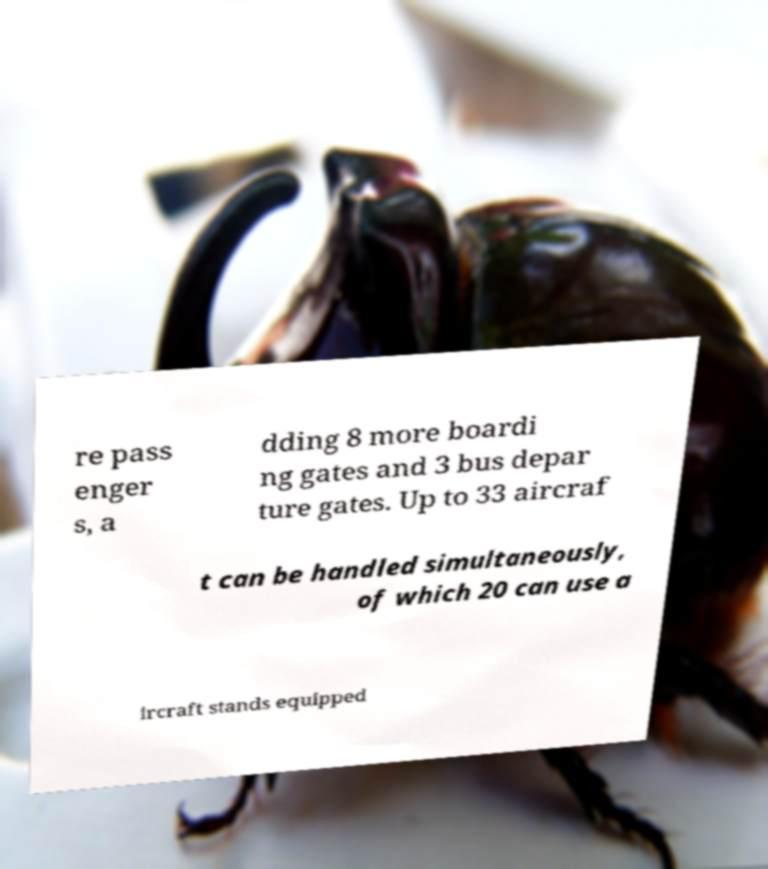Can you accurately transcribe the text from the provided image for me? re pass enger s, a dding 8 more boardi ng gates and 3 bus depar ture gates. Up to 33 aircraf t can be handled simultaneously, of which 20 can use a ircraft stands equipped 